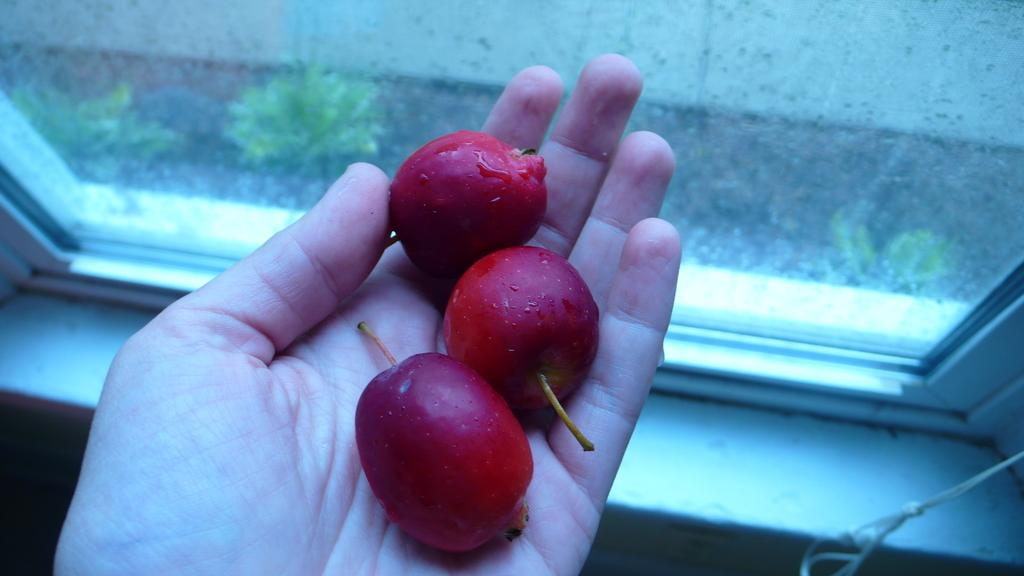What type of food is visible in the image? There are fruits in the image. Where are the fruits located? The fruits are on a hand in the image. What can be seen in the background of the image? The hand is in front of a window. What type of amusement can be seen in the image? There is no amusement present in the image; it features fruits on a hand in front of a window. How does the stomach appear in the image? There is no stomach visible in the image. 